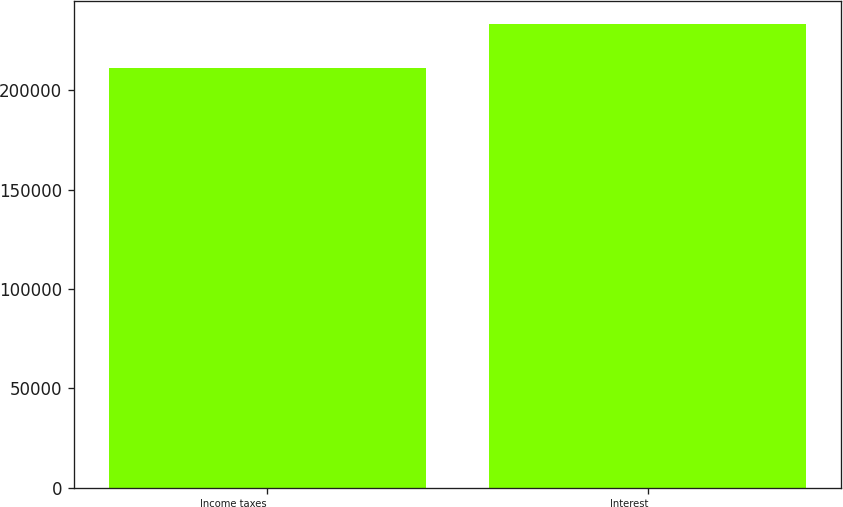Convert chart. <chart><loc_0><loc_0><loc_500><loc_500><bar_chart><fcel>Income taxes<fcel>Interest<nl><fcel>211473<fcel>233436<nl></chart> 